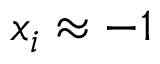Convert formula to latex. <formula><loc_0><loc_0><loc_500><loc_500>x _ { i } \approx - 1</formula> 